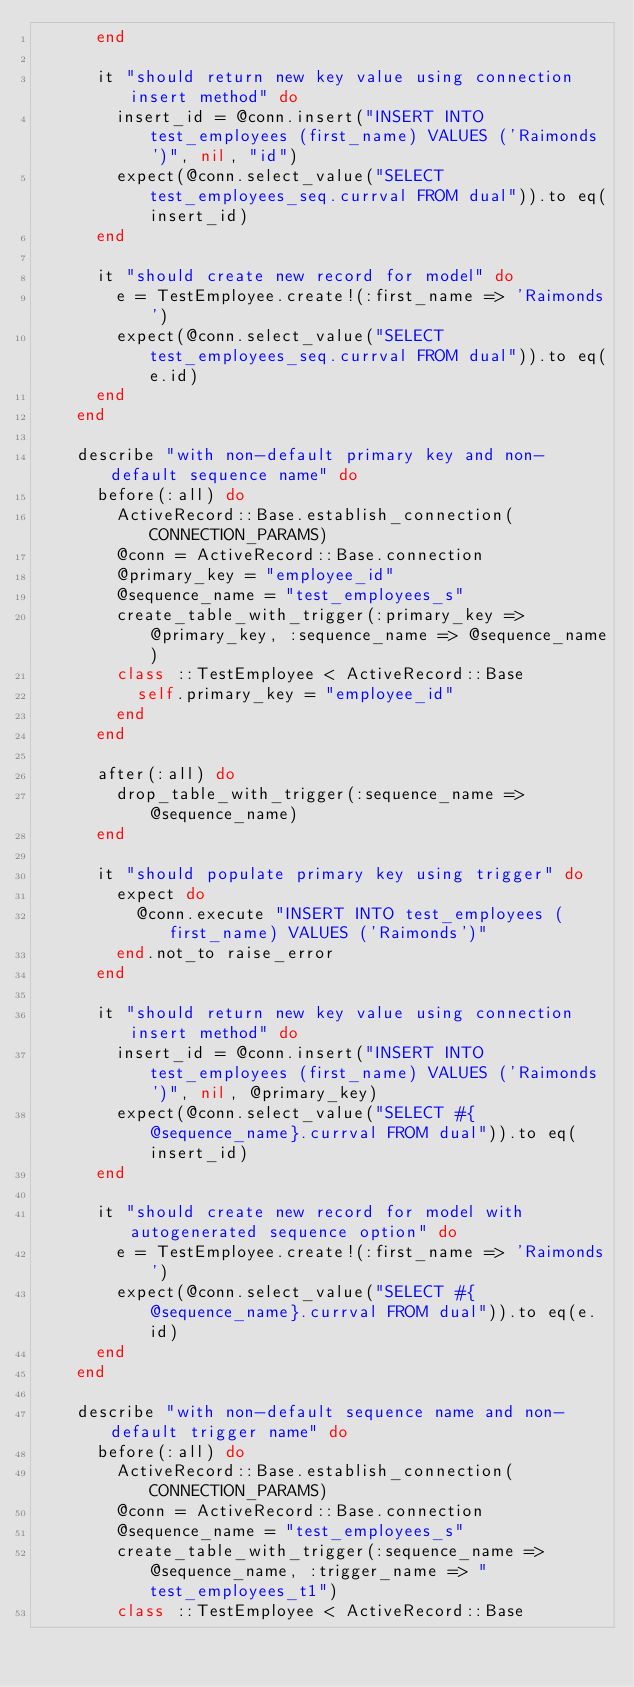<code> <loc_0><loc_0><loc_500><loc_500><_Ruby_>      end

      it "should return new key value using connection insert method" do
        insert_id = @conn.insert("INSERT INTO test_employees (first_name) VALUES ('Raimonds')", nil, "id")
        expect(@conn.select_value("SELECT test_employees_seq.currval FROM dual")).to eq(insert_id)
      end

      it "should create new record for model" do
        e = TestEmployee.create!(:first_name => 'Raimonds')
        expect(@conn.select_value("SELECT test_employees_seq.currval FROM dual")).to eq(e.id)
      end
    end

    describe "with non-default primary key and non-default sequence name" do
      before(:all) do
        ActiveRecord::Base.establish_connection(CONNECTION_PARAMS)
        @conn = ActiveRecord::Base.connection
        @primary_key = "employee_id"
        @sequence_name = "test_employees_s"
        create_table_with_trigger(:primary_key => @primary_key, :sequence_name => @sequence_name)
        class ::TestEmployee < ActiveRecord::Base
          self.primary_key = "employee_id"
        end
      end

      after(:all) do
        drop_table_with_trigger(:sequence_name => @sequence_name)
      end

      it "should populate primary key using trigger" do
        expect do
          @conn.execute "INSERT INTO test_employees (first_name) VALUES ('Raimonds')"
        end.not_to raise_error
      end

      it "should return new key value using connection insert method" do
        insert_id = @conn.insert("INSERT INTO test_employees (first_name) VALUES ('Raimonds')", nil, @primary_key)
        expect(@conn.select_value("SELECT #{@sequence_name}.currval FROM dual")).to eq(insert_id)
      end

      it "should create new record for model with autogenerated sequence option" do
        e = TestEmployee.create!(:first_name => 'Raimonds')
        expect(@conn.select_value("SELECT #{@sequence_name}.currval FROM dual")).to eq(e.id)
      end
    end

    describe "with non-default sequence name and non-default trigger name" do
      before(:all) do
        ActiveRecord::Base.establish_connection(CONNECTION_PARAMS)
        @conn = ActiveRecord::Base.connection
        @sequence_name = "test_employees_s"
        create_table_with_trigger(:sequence_name => @sequence_name, :trigger_name => "test_employees_t1")
        class ::TestEmployee < ActiveRecord::Base</code> 